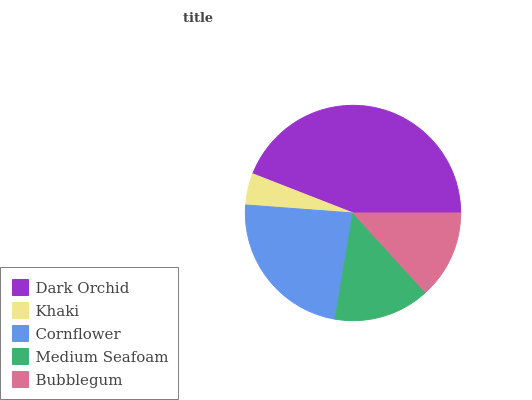Is Khaki the minimum?
Answer yes or no. Yes. Is Dark Orchid the maximum?
Answer yes or no. Yes. Is Cornflower the minimum?
Answer yes or no. No. Is Cornflower the maximum?
Answer yes or no. No. Is Cornflower greater than Khaki?
Answer yes or no. Yes. Is Khaki less than Cornflower?
Answer yes or no. Yes. Is Khaki greater than Cornflower?
Answer yes or no. No. Is Cornflower less than Khaki?
Answer yes or no. No. Is Medium Seafoam the high median?
Answer yes or no. Yes. Is Medium Seafoam the low median?
Answer yes or no. Yes. Is Khaki the high median?
Answer yes or no. No. Is Bubblegum the low median?
Answer yes or no. No. 